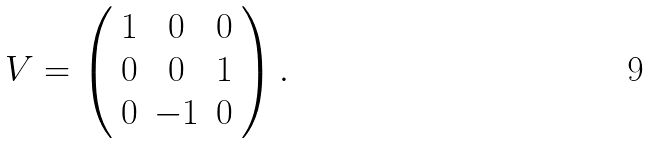Convert formula to latex. <formula><loc_0><loc_0><loc_500><loc_500>V = \left ( \begin{array} { c c c } 1 & 0 & 0 \\ 0 & 0 & 1 \\ 0 & - 1 & 0 \end{array} \right ) .</formula> 